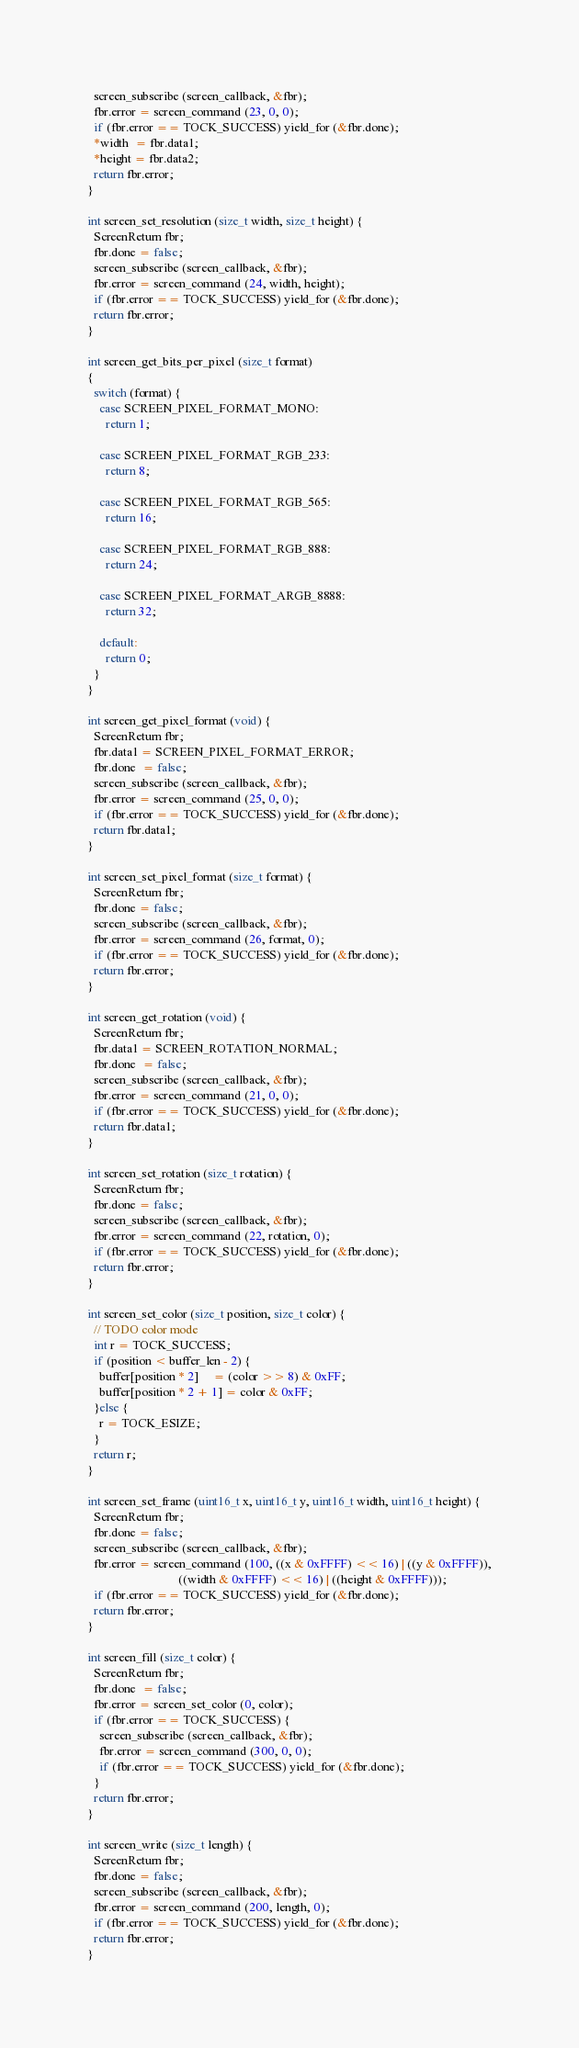<code> <loc_0><loc_0><loc_500><loc_500><_C_>  screen_subscribe (screen_callback, &fbr);
  fbr.error = screen_command (23, 0, 0);
  if (fbr.error == TOCK_SUCCESS) yield_for (&fbr.done);
  *width  = fbr.data1;
  *height = fbr.data2;
  return fbr.error;
}

int screen_set_resolution (size_t width, size_t height) {
  ScreenReturn fbr;
  fbr.done = false;
  screen_subscribe (screen_callback, &fbr);
  fbr.error = screen_command (24, width, height);
  if (fbr.error == TOCK_SUCCESS) yield_for (&fbr.done);
  return fbr.error;
}

int screen_get_bits_per_pixel (size_t format)
{
  switch (format) {
    case SCREEN_PIXEL_FORMAT_MONO:
      return 1;

    case SCREEN_PIXEL_FORMAT_RGB_233:
      return 8;

    case SCREEN_PIXEL_FORMAT_RGB_565:
      return 16;

    case SCREEN_PIXEL_FORMAT_RGB_888:
      return 24;

    case SCREEN_PIXEL_FORMAT_ARGB_8888:
      return 32;

    default:
      return 0;
  }
}

int screen_get_pixel_format (void) {
  ScreenReturn fbr;
  fbr.data1 = SCREEN_PIXEL_FORMAT_ERROR;
  fbr.done  = false;
  screen_subscribe (screen_callback, &fbr);
  fbr.error = screen_command (25, 0, 0);
  if (fbr.error == TOCK_SUCCESS) yield_for (&fbr.done);
  return fbr.data1;
}

int screen_set_pixel_format (size_t format) {
  ScreenReturn fbr;
  fbr.done = false;
  screen_subscribe (screen_callback, &fbr);
  fbr.error = screen_command (26, format, 0);
  if (fbr.error == TOCK_SUCCESS) yield_for (&fbr.done);
  return fbr.error;
}

int screen_get_rotation (void) {
  ScreenReturn fbr;
  fbr.data1 = SCREEN_ROTATION_NORMAL;
  fbr.done  = false;
  screen_subscribe (screen_callback, &fbr);
  fbr.error = screen_command (21, 0, 0);
  if (fbr.error == TOCK_SUCCESS) yield_for (&fbr.done);
  return fbr.data1;
}

int screen_set_rotation (size_t rotation) {
  ScreenReturn fbr;
  fbr.done = false;
  screen_subscribe (screen_callback, &fbr);
  fbr.error = screen_command (22, rotation, 0);
  if (fbr.error == TOCK_SUCCESS) yield_for (&fbr.done);
  return fbr.error;
}

int screen_set_color (size_t position, size_t color) {
  // TODO color mode
  int r = TOCK_SUCCESS;
  if (position < buffer_len - 2) {
    buffer[position * 2]     = (color >> 8) & 0xFF;
    buffer[position * 2 + 1] = color & 0xFF;
  }else {
    r = TOCK_ESIZE;
  }
  return r;
}

int screen_set_frame (uint16_t x, uint16_t y, uint16_t width, uint16_t height) {
  ScreenReturn fbr;
  fbr.done = false;
  screen_subscribe (screen_callback, &fbr);
  fbr.error = screen_command (100, ((x & 0xFFFF) << 16) | ((y & 0xFFFF)),
                              ((width & 0xFFFF) << 16) | ((height & 0xFFFF)));
  if (fbr.error == TOCK_SUCCESS) yield_for (&fbr.done);
  return fbr.error;
}

int screen_fill (size_t color) {
  ScreenReturn fbr;
  fbr.done  = false;
  fbr.error = screen_set_color (0, color);
  if (fbr.error == TOCK_SUCCESS) {
    screen_subscribe (screen_callback, &fbr);
    fbr.error = screen_command (300, 0, 0);
    if (fbr.error == TOCK_SUCCESS) yield_for (&fbr.done);
  }
  return fbr.error;
}

int screen_write (size_t length) {
  ScreenReturn fbr;
  fbr.done = false;
  screen_subscribe (screen_callback, &fbr);
  fbr.error = screen_command (200, length, 0);
  if (fbr.error == TOCK_SUCCESS) yield_for (&fbr.done);
  return fbr.error;
}</code> 